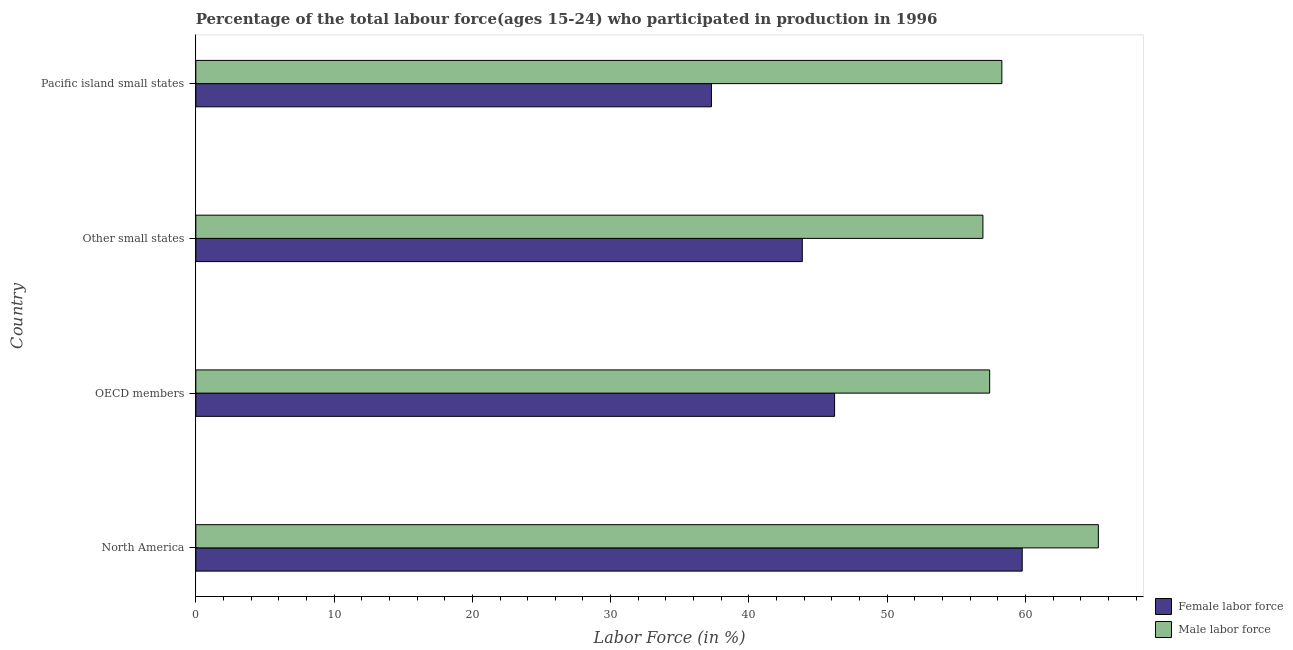How many different coloured bars are there?
Ensure brevity in your answer.  2. How many groups of bars are there?
Your answer should be very brief. 4. Are the number of bars on each tick of the Y-axis equal?
Your response must be concise. Yes. What is the label of the 3rd group of bars from the top?
Offer a terse response. OECD members. In how many cases, is the number of bars for a given country not equal to the number of legend labels?
Your answer should be compact. 0. What is the percentage of male labour force in Other small states?
Make the answer very short. 56.93. Across all countries, what is the maximum percentage of male labour force?
Offer a terse response. 65.27. Across all countries, what is the minimum percentage of male labour force?
Your answer should be compact. 56.93. In which country was the percentage of male labour force minimum?
Give a very brief answer. Other small states. What is the total percentage of male labour force in the graph?
Make the answer very short. 237.91. What is the difference between the percentage of male labour force in North America and that in Other small states?
Your response must be concise. 8.35. What is the difference between the percentage of female labor force in Pacific island small states and the percentage of male labour force in Other small states?
Offer a very short reply. -19.64. What is the average percentage of male labour force per country?
Your response must be concise. 59.48. What is the difference between the percentage of male labour force and percentage of female labor force in Other small states?
Offer a terse response. 13.06. In how many countries, is the percentage of female labor force greater than 22 %?
Keep it short and to the point. 4. What is the difference between the highest and the second highest percentage of female labor force?
Your answer should be very brief. 13.57. What is the difference between the highest and the lowest percentage of female labor force?
Ensure brevity in your answer.  22.48. In how many countries, is the percentage of male labour force greater than the average percentage of male labour force taken over all countries?
Offer a terse response. 1. Is the sum of the percentage of female labor force in OECD members and Pacific island small states greater than the maximum percentage of male labour force across all countries?
Offer a terse response. Yes. What does the 2nd bar from the top in North America represents?
Offer a very short reply. Female labor force. What does the 2nd bar from the bottom in North America represents?
Your response must be concise. Male labor force. Are all the bars in the graph horizontal?
Your answer should be very brief. Yes. How many countries are there in the graph?
Offer a terse response. 4. Are the values on the major ticks of X-axis written in scientific E-notation?
Offer a terse response. No. Does the graph contain any zero values?
Provide a succinct answer. No. What is the title of the graph?
Provide a succinct answer. Percentage of the total labour force(ages 15-24) who participated in production in 1996. Does "Young" appear as one of the legend labels in the graph?
Offer a very short reply. No. What is the label or title of the X-axis?
Offer a terse response. Labor Force (in %). What is the label or title of the Y-axis?
Offer a very short reply. Country. What is the Labor Force (in %) in Female labor force in North America?
Your response must be concise. 59.77. What is the Labor Force (in %) of Male labor force in North America?
Give a very brief answer. 65.27. What is the Labor Force (in %) of Female labor force in OECD members?
Offer a very short reply. 46.2. What is the Labor Force (in %) in Male labor force in OECD members?
Make the answer very short. 57.41. What is the Labor Force (in %) of Female labor force in Other small states?
Offer a very short reply. 43.86. What is the Labor Force (in %) of Male labor force in Other small states?
Your answer should be compact. 56.93. What is the Labor Force (in %) of Female labor force in Pacific island small states?
Your answer should be compact. 37.29. What is the Labor Force (in %) in Male labor force in Pacific island small states?
Your answer should be compact. 58.3. Across all countries, what is the maximum Labor Force (in %) of Female labor force?
Your answer should be compact. 59.77. Across all countries, what is the maximum Labor Force (in %) of Male labor force?
Ensure brevity in your answer.  65.27. Across all countries, what is the minimum Labor Force (in %) of Female labor force?
Your answer should be compact. 37.29. Across all countries, what is the minimum Labor Force (in %) in Male labor force?
Make the answer very short. 56.93. What is the total Labor Force (in %) of Female labor force in the graph?
Your answer should be very brief. 187.12. What is the total Labor Force (in %) in Male labor force in the graph?
Make the answer very short. 237.91. What is the difference between the Labor Force (in %) in Female labor force in North America and that in OECD members?
Give a very brief answer. 13.57. What is the difference between the Labor Force (in %) in Male labor force in North America and that in OECD members?
Make the answer very short. 7.86. What is the difference between the Labor Force (in %) of Female labor force in North America and that in Other small states?
Keep it short and to the point. 15.91. What is the difference between the Labor Force (in %) of Male labor force in North America and that in Other small states?
Keep it short and to the point. 8.35. What is the difference between the Labor Force (in %) of Female labor force in North America and that in Pacific island small states?
Offer a very short reply. 22.48. What is the difference between the Labor Force (in %) in Male labor force in North America and that in Pacific island small states?
Provide a short and direct response. 6.98. What is the difference between the Labor Force (in %) in Female labor force in OECD members and that in Other small states?
Provide a succinct answer. 2.34. What is the difference between the Labor Force (in %) of Male labor force in OECD members and that in Other small states?
Provide a succinct answer. 0.49. What is the difference between the Labor Force (in %) of Female labor force in OECD members and that in Pacific island small states?
Your answer should be very brief. 8.91. What is the difference between the Labor Force (in %) of Male labor force in OECD members and that in Pacific island small states?
Make the answer very short. -0.88. What is the difference between the Labor Force (in %) of Female labor force in Other small states and that in Pacific island small states?
Ensure brevity in your answer.  6.57. What is the difference between the Labor Force (in %) in Male labor force in Other small states and that in Pacific island small states?
Offer a very short reply. -1.37. What is the difference between the Labor Force (in %) of Female labor force in North America and the Labor Force (in %) of Male labor force in OECD members?
Keep it short and to the point. 2.35. What is the difference between the Labor Force (in %) in Female labor force in North America and the Labor Force (in %) in Male labor force in Other small states?
Your answer should be very brief. 2.84. What is the difference between the Labor Force (in %) of Female labor force in North America and the Labor Force (in %) of Male labor force in Pacific island small states?
Give a very brief answer. 1.47. What is the difference between the Labor Force (in %) in Female labor force in OECD members and the Labor Force (in %) in Male labor force in Other small states?
Give a very brief answer. -10.73. What is the difference between the Labor Force (in %) in Female labor force in OECD members and the Labor Force (in %) in Male labor force in Pacific island small states?
Keep it short and to the point. -12.1. What is the difference between the Labor Force (in %) of Female labor force in Other small states and the Labor Force (in %) of Male labor force in Pacific island small states?
Keep it short and to the point. -14.43. What is the average Labor Force (in %) in Female labor force per country?
Offer a terse response. 46.78. What is the average Labor Force (in %) of Male labor force per country?
Keep it short and to the point. 59.48. What is the difference between the Labor Force (in %) of Female labor force and Labor Force (in %) of Male labor force in North America?
Your answer should be compact. -5.51. What is the difference between the Labor Force (in %) in Female labor force and Labor Force (in %) in Male labor force in OECD members?
Keep it short and to the point. -11.22. What is the difference between the Labor Force (in %) in Female labor force and Labor Force (in %) in Male labor force in Other small states?
Your answer should be compact. -13.06. What is the difference between the Labor Force (in %) of Female labor force and Labor Force (in %) of Male labor force in Pacific island small states?
Your answer should be very brief. -21. What is the ratio of the Labor Force (in %) of Female labor force in North America to that in OECD members?
Keep it short and to the point. 1.29. What is the ratio of the Labor Force (in %) in Male labor force in North America to that in OECD members?
Your answer should be very brief. 1.14. What is the ratio of the Labor Force (in %) in Female labor force in North America to that in Other small states?
Your answer should be very brief. 1.36. What is the ratio of the Labor Force (in %) of Male labor force in North America to that in Other small states?
Provide a short and direct response. 1.15. What is the ratio of the Labor Force (in %) of Female labor force in North America to that in Pacific island small states?
Provide a succinct answer. 1.6. What is the ratio of the Labor Force (in %) in Male labor force in North America to that in Pacific island small states?
Provide a succinct answer. 1.12. What is the ratio of the Labor Force (in %) in Female labor force in OECD members to that in Other small states?
Ensure brevity in your answer.  1.05. What is the ratio of the Labor Force (in %) in Male labor force in OECD members to that in Other small states?
Make the answer very short. 1.01. What is the ratio of the Labor Force (in %) in Female labor force in OECD members to that in Pacific island small states?
Offer a very short reply. 1.24. What is the ratio of the Labor Force (in %) in Male labor force in OECD members to that in Pacific island small states?
Offer a terse response. 0.98. What is the ratio of the Labor Force (in %) of Female labor force in Other small states to that in Pacific island small states?
Keep it short and to the point. 1.18. What is the ratio of the Labor Force (in %) of Male labor force in Other small states to that in Pacific island small states?
Ensure brevity in your answer.  0.98. What is the difference between the highest and the second highest Labor Force (in %) of Female labor force?
Provide a short and direct response. 13.57. What is the difference between the highest and the second highest Labor Force (in %) in Male labor force?
Offer a very short reply. 6.98. What is the difference between the highest and the lowest Labor Force (in %) of Female labor force?
Keep it short and to the point. 22.48. What is the difference between the highest and the lowest Labor Force (in %) of Male labor force?
Offer a terse response. 8.35. 